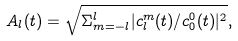Convert formula to latex. <formula><loc_0><loc_0><loc_500><loc_500>A _ { l } ( t ) = \sqrt { \Sigma ^ { l } _ { m = - l } | c ^ { m } _ { l } ( t ) / c ^ { 0 } _ { 0 } ( t ) | ^ { 2 } } ,</formula> 